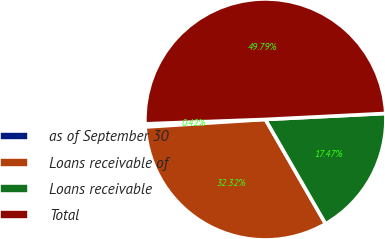<chart> <loc_0><loc_0><loc_500><loc_500><pie_chart><fcel>as of September 30<fcel>Loans receivable of<fcel>Loans receivable<fcel>Total<nl><fcel>0.42%<fcel>32.32%<fcel>17.47%<fcel>49.79%<nl></chart> 